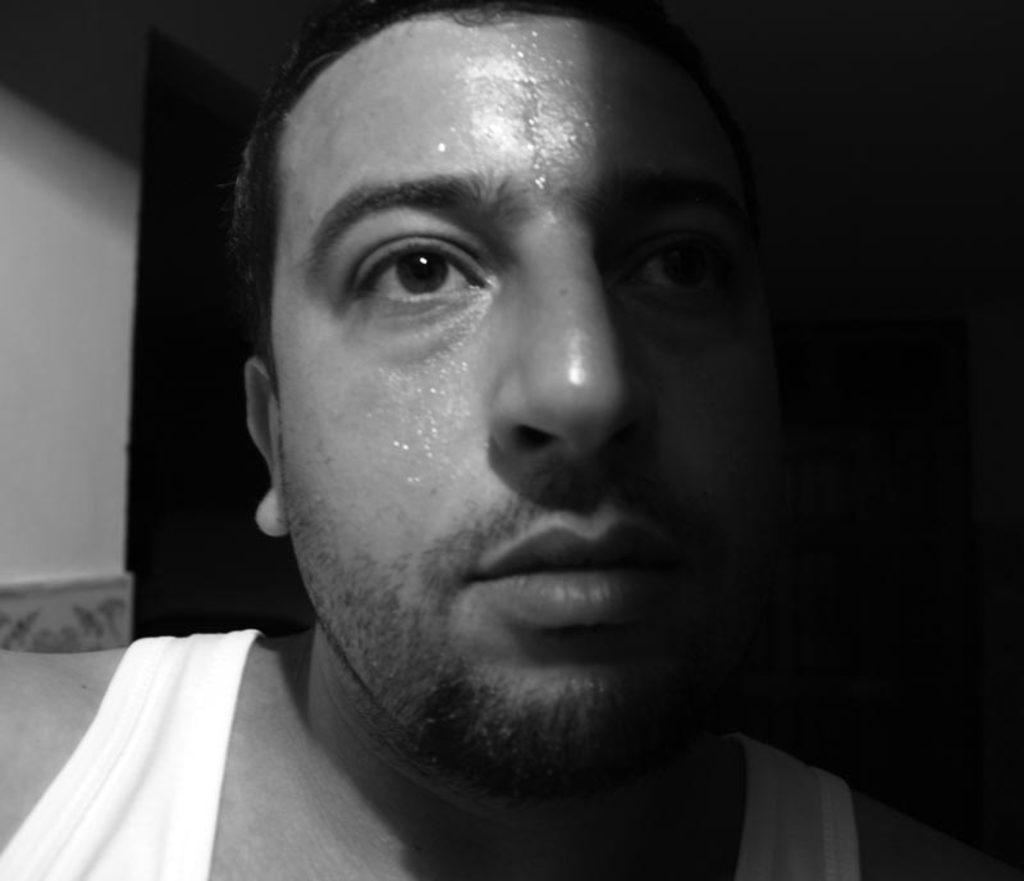Describe this image in one or two sentences. In this picture I can see there is a man, he is sweating and there is a wall on the left side and the backdrop is dark at the right side. 